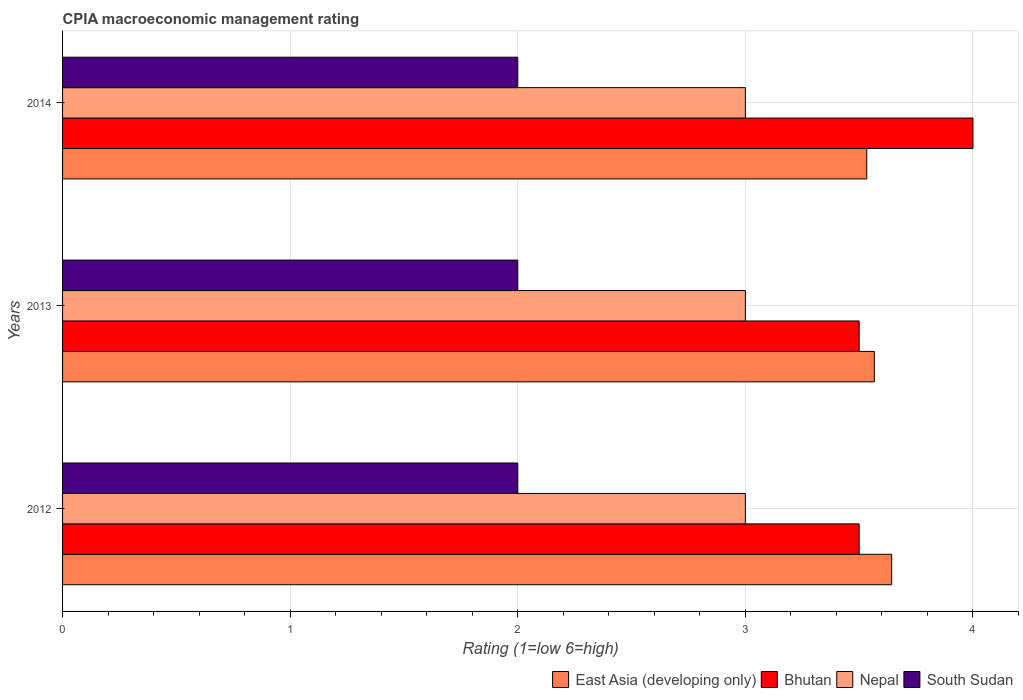How many different coloured bars are there?
Keep it short and to the point. 4. Are the number of bars on each tick of the Y-axis equal?
Keep it short and to the point. Yes. In which year was the CPIA rating in Bhutan maximum?
Offer a terse response. 2014. In which year was the CPIA rating in South Sudan minimum?
Provide a succinct answer. 2012. What is the difference between the CPIA rating in East Asia (developing only) in 2013 and that in 2014?
Keep it short and to the point. 0.03. What is the difference between the CPIA rating in Bhutan in 2014 and the CPIA rating in Nepal in 2013?
Provide a short and direct response. 1. What is the average CPIA rating in East Asia (developing only) per year?
Keep it short and to the point. 3.58. Is the CPIA rating in Bhutan in 2013 less than that in 2014?
Provide a short and direct response. Yes. What is the difference between the highest and the second highest CPIA rating in Bhutan?
Provide a short and direct response. 0.5. What is the difference between the highest and the lowest CPIA rating in East Asia (developing only)?
Offer a terse response. 0.11. In how many years, is the CPIA rating in Nepal greater than the average CPIA rating in Nepal taken over all years?
Your answer should be compact. 0. Is the sum of the CPIA rating in South Sudan in 2012 and 2014 greater than the maximum CPIA rating in Bhutan across all years?
Provide a short and direct response. No. Is it the case that in every year, the sum of the CPIA rating in Nepal and CPIA rating in East Asia (developing only) is greater than the sum of CPIA rating in Bhutan and CPIA rating in South Sudan?
Provide a succinct answer. Yes. What does the 2nd bar from the top in 2012 represents?
Provide a succinct answer. Nepal. What does the 2nd bar from the bottom in 2012 represents?
Offer a terse response. Bhutan. Is it the case that in every year, the sum of the CPIA rating in East Asia (developing only) and CPIA rating in Nepal is greater than the CPIA rating in Bhutan?
Give a very brief answer. Yes. How many bars are there?
Your answer should be very brief. 12. Are the values on the major ticks of X-axis written in scientific E-notation?
Ensure brevity in your answer.  No. Does the graph contain any zero values?
Provide a succinct answer. No. Where does the legend appear in the graph?
Offer a very short reply. Bottom right. How are the legend labels stacked?
Your answer should be very brief. Horizontal. What is the title of the graph?
Provide a short and direct response. CPIA macroeconomic management rating. What is the label or title of the Y-axis?
Your answer should be compact. Years. What is the Rating (1=low 6=high) of East Asia (developing only) in 2012?
Your answer should be compact. 3.64. What is the Rating (1=low 6=high) in Bhutan in 2012?
Provide a succinct answer. 3.5. What is the Rating (1=low 6=high) of Nepal in 2012?
Keep it short and to the point. 3. What is the Rating (1=low 6=high) of South Sudan in 2012?
Offer a terse response. 2. What is the Rating (1=low 6=high) of East Asia (developing only) in 2013?
Your answer should be very brief. 3.57. What is the Rating (1=low 6=high) of Bhutan in 2013?
Ensure brevity in your answer.  3.5. What is the Rating (1=low 6=high) of South Sudan in 2013?
Offer a very short reply. 2. What is the Rating (1=low 6=high) of East Asia (developing only) in 2014?
Provide a short and direct response. 3.53. What is the Rating (1=low 6=high) of Nepal in 2014?
Your answer should be very brief. 3. Across all years, what is the maximum Rating (1=low 6=high) in East Asia (developing only)?
Provide a succinct answer. 3.64. Across all years, what is the maximum Rating (1=low 6=high) of South Sudan?
Ensure brevity in your answer.  2. Across all years, what is the minimum Rating (1=low 6=high) of East Asia (developing only)?
Your answer should be very brief. 3.53. What is the total Rating (1=low 6=high) in East Asia (developing only) in the graph?
Keep it short and to the point. 10.74. What is the total Rating (1=low 6=high) of South Sudan in the graph?
Make the answer very short. 6. What is the difference between the Rating (1=low 6=high) of East Asia (developing only) in 2012 and that in 2013?
Provide a succinct answer. 0.08. What is the difference between the Rating (1=low 6=high) of Bhutan in 2012 and that in 2013?
Offer a very short reply. 0. What is the difference between the Rating (1=low 6=high) in Nepal in 2012 and that in 2013?
Keep it short and to the point. 0. What is the difference between the Rating (1=low 6=high) in East Asia (developing only) in 2012 and that in 2014?
Keep it short and to the point. 0.11. What is the difference between the Rating (1=low 6=high) in Nepal in 2012 and that in 2014?
Ensure brevity in your answer.  0. What is the difference between the Rating (1=low 6=high) of South Sudan in 2012 and that in 2014?
Offer a terse response. 0. What is the difference between the Rating (1=low 6=high) of East Asia (developing only) in 2013 and that in 2014?
Offer a terse response. 0.03. What is the difference between the Rating (1=low 6=high) in Bhutan in 2013 and that in 2014?
Offer a terse response. -0.5. What is the difference between the Rating (1=low 6=high) of East Asia (developing only) in 2012 and the Rating (1=low 6=high) of Bhutan in 2013?
Offer a terse response. 0.14. What is the difference between the Rating (1=low 6=high) of East Asia (developing only) in 2012 and the Rating (1=low 6=high) of Nepal in 2013?
Provide a short and direct response. 0.64. What is the difference between the Rating (1=low 6=high) in East Asia (developing only) in 2012 and the Rating (1=low 6=high) in South Sudan in 2013?
Offer a terse response. 1.64. What is the difference between the Rating (1=low 6=high) in Bhutan in 2012 and the Rating (1=low 6=high) in South Sudan in 2013?
Your answer should be very brief. 1.5. What is the difference between the Rating (1=low 6=high) in East Asia (developing only) in 2012 and the Rating (1=low 6=high) in Bhutan in 2014?
Your response must be concise. -0.36. What is the difference between the Rating (1=low 6=high) of East Asia (developing only) in 2012 and the Rating (1=low 6=high) of Nepal in 2014?
Make the answer very short. 0.64. What is the difference between the Rating (1=low 6=high) of East Asia (developing only) in 2012 and the Rating (1=low 6=high) of South Sudan in 2014?
Offer a very short reply. 1.64. What is the difference between the Rating (1=low 6=high) of Nepal in 2012 and the Rating (1=low 6=high) of South Sudan in 2014?
Your answer should be compact. 1. What is the difference between the Rating (1=low 6=high) in East Asia (developing only) in 2013 and the Rating (1=low 6=high) in Bhutan in 2014?
Your answer should be compact. -0.43. What is the difference between the Rating (1=low 6=high) of East Asia (developing only) in 2013 and the Rating (1=low 6=high) of Nepal in 2014?
Offer a terse response. 0.57. What is the difference between the Rating (1=low 6=high) in East Asia (developing only) in 2013 and the Rating (1=low 6=high) in South Sudan in 2014?
Keep it short and to the point. 1.57. What is the difference between the Rating (1=low 6=high) in Bhutan in 2013 and the Rating (1=low 6=high) in Nepal in 2014?
Make the answer very short. 0.5. What is the difference between the Rating (1=low 6=high) of Bhutan in 2013 and the Rating (1=low 6=high) of South Sudan in 2014?
Provide a short and direct response. 1.5. What is the difference between the Rating (1=low 6=high) of Nepal in 2013 and the Rating (1=low 6=high) of South Sudan in 2014?
Provide a short and direct response. 1. What is the average Rating (1=low 6=high) of East Asia (developing only) per year?
Your answer should be compact. 3.58. What is the average Rating (1=low 6=high) in Bhutan per year?
Provide a succinct answer. 3.67. In the year 2012, what is the difference between the Rating (1=low 6=high) of East Asia (developing only) and Rating (1=low 6=high) of Bhutan?
Make the answer very short. 0.14. In the year 2012, what is the difference between the Rating (1=low 6=high) in East Asia (developing only) and Rating (1=low 6=high) in Nepal?
Provide a short and direct response. 0.64. In the year 2012, what is the difference between the Rating (1=low 6=high) in East Asia (developing only) and Rating (1=low 6=high) in South Sudan?
Give a very brief answer. 1.64. In the year 2012, what is the difference between the Rating (1=low 6=high) in Bhutan and Rating (1=low 6=high) in Nepal?
Your answer should be compact. 0.5. In the year 2013, what is the difference between the Rating (1=low 6=high) in East Asia (developing only) and Rating (1=low 6=high) in Bhutan?
Your response must be concise. 0.07. In the year 2013, what is the difference between the Rating (1=low 6=high) of East Asia (developing only) and Rating (1=low 6=high) of Nepal?
Your response must be concise. 0.57. In the year 2013, what is the difference between the Rating (1=low 6=high) in East Asia (developing only) and Rating (1=low 6=high) in South Sudan?
Offer a terse response. 1.57. In the year 2013, what is the difference between the Rating (1=low 6=high) of Bhutan and Rating (1=low 6=high) of Nepal?
Your answer should be very brief. 0.5. In the year 2013, what is the difference between the Rating (1=low 6=high) of Bhutan and Rating (1=low 6=high) of South Sudan?
Keep it short and to the point. 1.5. In the year 2013, what is the difference between the Rating (1=low 6=high) in Nepal and Rating (1=low 6=high) in South Sudan?
Provide a short and direct response. 1. In the year 2014, what is the difference between the Rating (1=low 6=high) in East Asia (developing only) and Rating (1=low 6=high) in Bhutan?
Keep it short and to the point. -0.47. In the year 2014, what is the difference between the Rating (1=low 6=high) of East Asia (developing only) and Rating (1=low 6=high) of Nepal?
Provide a succinct answer. 0.53. In the year 2014, what is the difference between the Rating (1=low 6=high) of East Asia (developing only) and Rating (1=low 6=high) of South Sudan?
Provide a short and direct response. 1.53. In the year 2014, what is the difference between the Rating (1=low 6=high) of Bhutan and Rating (1=low 6=high) of Nepal?
Your answer should be very brief. 1. In the year 2014, what is the difference between the Rating (1=low 6=high) of Bhutan and Rating (1=low 6=high) of South Sudan?
Give a very brief answer. 2. What is the ratio of the Rating (1=low 6=high) in East Asia (developing only) in 2012 to that in 2013?
Keep it short and to the point. 1.02. What is the ratio of the Rating (1=low 6=high) in Bhutan in 2012 to that in 2013?
Give a very brief answer. 1. What is the ratio of the Rating (1=low 6=high) of Nepal in 2012 to that in 2013?
Ensure brevity in your answer.  1. What is the ratio of the Rating (1=low 6=high) in East Asia (developing only) in 2012 to that in 2014?
Your answer should be very brief. 1.03. What is the ratio of the Rating (1=low 6=high) of Bhutan in 2012 to that in 2014?
Provide a succinct answer. 0.88. What is the ratio of the Rating (1=low 6=high) in East Asia (developing only) in 2013 to that in 2014?
Give a very brief answer. 1.01. What is the ratio of the Rating (1=low 6=high) of Nepal in 2013 to that in 2014?
Offer a terse response. 1. What is the ratio of the Rating (1=low 6=high) of South Sudan in 2013 to that in 2014?
Your answer should be very brief. 1. What is the difference between the highest and the second highest Rating (1=low 6=high) of East Asia (developing only)?
Your answer should be very brief. 0.08. What is the difference between the highest and the second highest Rating (1=low 6=high) of Bhutan?
Your answer should be compact. 0.5. What is the difference between the highest and the second highest Rating (1=low 6=high) in Nepal?
Provide a short and direct response. 0. What is the difference between the highest and the lowest Rating (1=low 6=high) of East Asia (developing only)?
Your answer should be very brief. 0.11. What is the difference between the highest and the lowest Rating (1=low 6=high) of Bhutan?
Your answer should be compact. 0.5. 